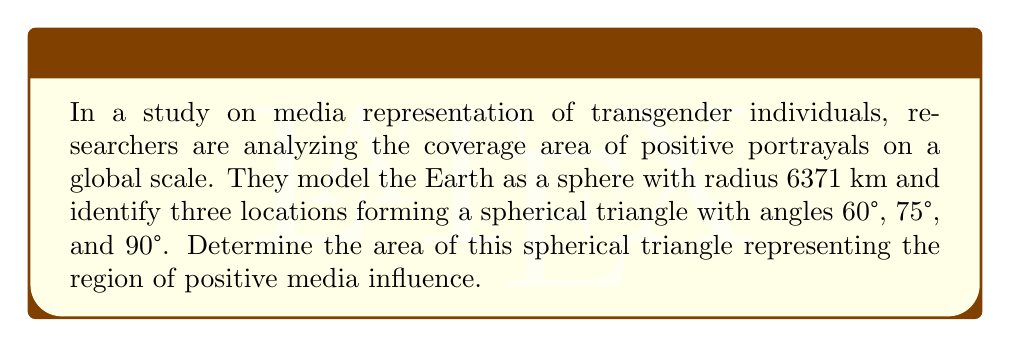Solve this math problem. To solve this problem, we'll use the formula for the area of a spherical triangle:

$$A = R^2 (\alpha + \beta + \gamma - \pi)$$

Where:
- $A$ is the area of the spherical triangle
- $R$ is the radius of the sphere
- $\alpha$, $\beta$, and $\gamma$ are the angles of the spherical triangle in radians

Step 1: Convert the given angles from degrees to radians:
$60° = \frac{\pi}{3}$ rad
$75° = \frac{5\pi}{12}$ rad
$90° = \frac{\pi}{2}$ rad

Step 2: Sum the angles:
$$\alpha + \beta + \gamma = \frac{\pi}{3} + \frac{5\pi}{12} + \frac{\pi}{2} = \frac{25\pi}{12}$$

Step 3: Subtract $\pi$ from the sum:
$$\frac{25\pi}{12} - \pi = \frac{13\pi}{12}$$

Step 4: Apply the formula:
$$A = (6371 \text{ km})^2 \cdot \frac{13\pi}{12}$$

Step 5: Calculate the result:
$$A = 40,589,441 \text{ km}^2 \cdot \frac{13\pi}{12} \approx 4,398,576 \text{ km}^2$$
Answer: $4,398,576 \text{ km}^2$ 